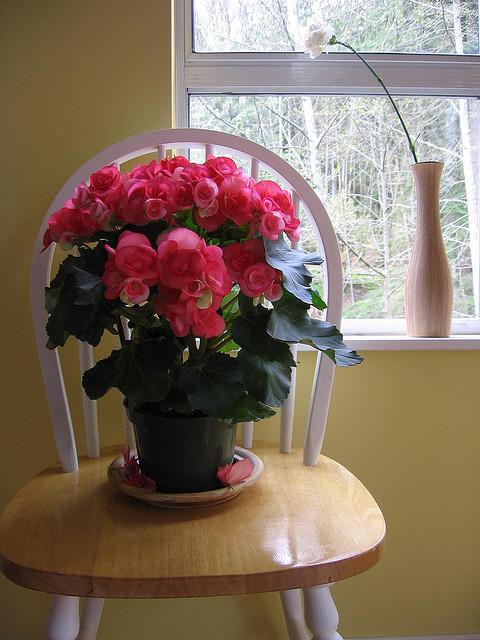What is on the window sill?
Be succinct. Vase. What color are the flowers?
Give a very brief answer. Pink. What type of flower is in the pot?
Quick response, please. Roses. 